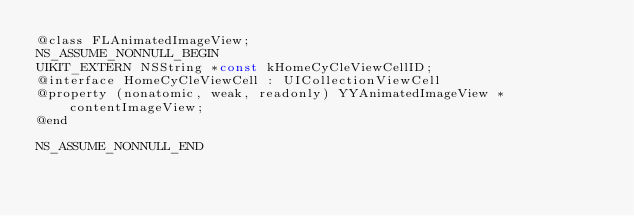Convert code to text. <code><loc_0><loc_0><loc_500><loc_500><_C_>@class FLAnimatedImageView;
NS_ASSUME_NONNULL_BEGIN
UIKIT_EXTERN NSString *const kHomeCyCleViewCellID;
@interface HomeCyCleViewCell : UICollectionViewCell
@property (nonatomic, weak, readonly) YYAnimatedImageView *contentImageView;
@end

NS_ASSUME_NONNULL_END
</code> 